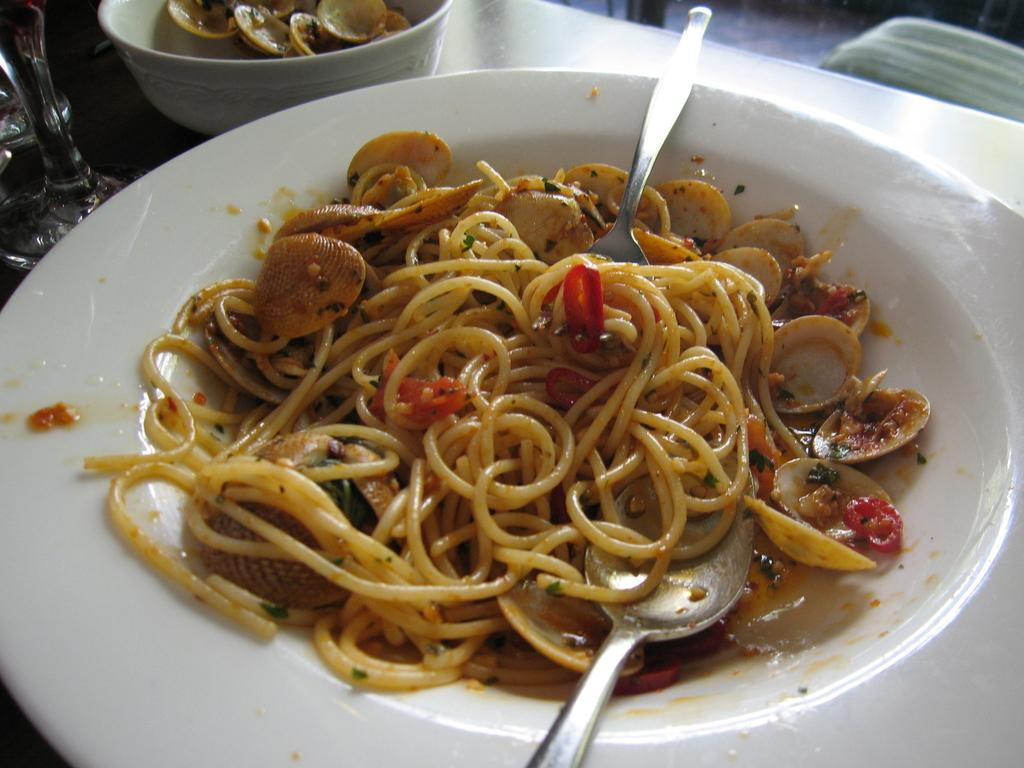What piece of furniture is present in the image? There is a table in the image. What can be found on the table? There are food items in containers on the table. What type of objects are located at the top left of the image? There are glass objects at the top left of the image. What utensils are visible in the image? There are spoons visible in the image. What is located at the top right of the image? There is an object on the top right of the image. What type of cord is being used to tie the furniture together in the image? There is no cord present in the image, and the furniture is not tied together. What level of respect can be observed between the objects in the image? The concept of respect does not apply to objects in the image, as respect is a human emotion and interaction. 